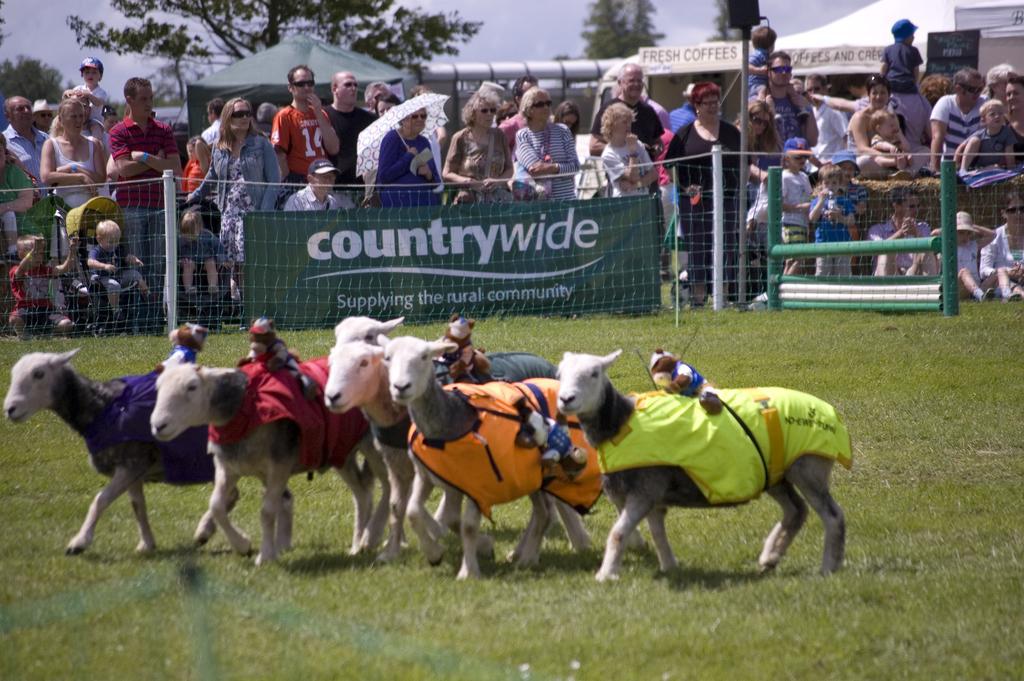Could you give a brief overview of what you see in this image? In this image there are herd of goats with shirts and toys on it , and there are group of people standing, next, board , tents, trees,sky. 